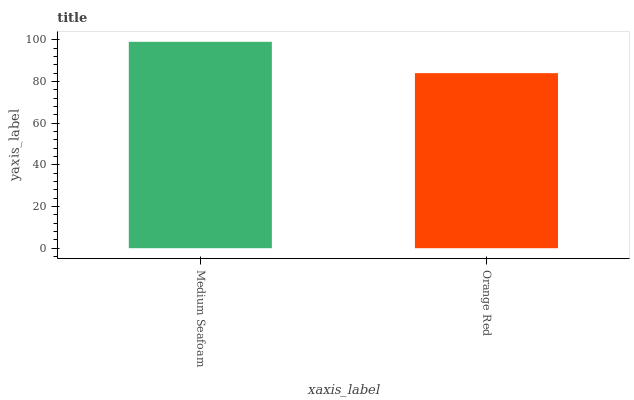Is Orange Red the maximum?
Answer yes or no. No. Is Medium Seafoam greater than Orange Red?
Answer yes or no. Yes. Is Orange Red less than Medium Seafoam?
Answer yes or no. Yes. Is Orange Red greater than Medium Seafoam?
Answer yes or no. No. Is Medium Seafoam less than Orange Red?
Answer yes or no. No. Is Medium Seafoam the high median?
Answer yes or no. Yes. Is Orange Red the low median?
Answer yes or no. Yes. Is Orange Red the high median?
Answer yes or no. No. Is Medium Seafoam the low median?
Answer yes or no. No. 